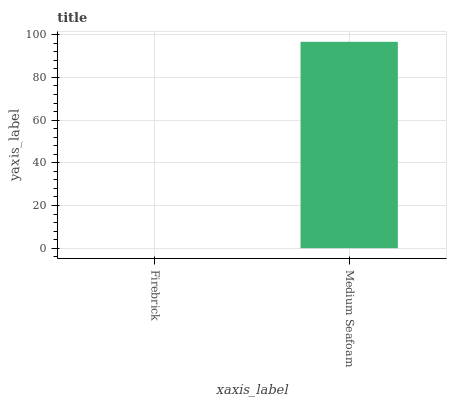Is Firebrick the minimum?
Answer yes or no. Yes. Is Medium Seafoam the maximum?
Answer yes or no. Yes. Is Medium Seafoam the minimum?
Answer yes or no. No. Is Medium Seafoam greater than Firebrick?
Answer yes or no. Yes. Is Firebrick less than Medium Seafoam?
Answer yes or no. Yes. Is Firebrick greater than Medium Seafoam?
Answer yes or no. No. Is Medium Seafoam less than Firebrick?
Answer yes or no. No. Is Medium Seafoam the high median?
Answer yes or no. Yes. Is Firebrick the low median?
Answer yes or no. Yes. Is Firebrick the high median?
Answer yes or no. No. Is Medium Seafoam the low median?
Answer yes or no. No. 